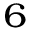Convert formula to latex. <formula><loc_0><loc_0><loc_500><loc_500>_ { 6 }</formula> 